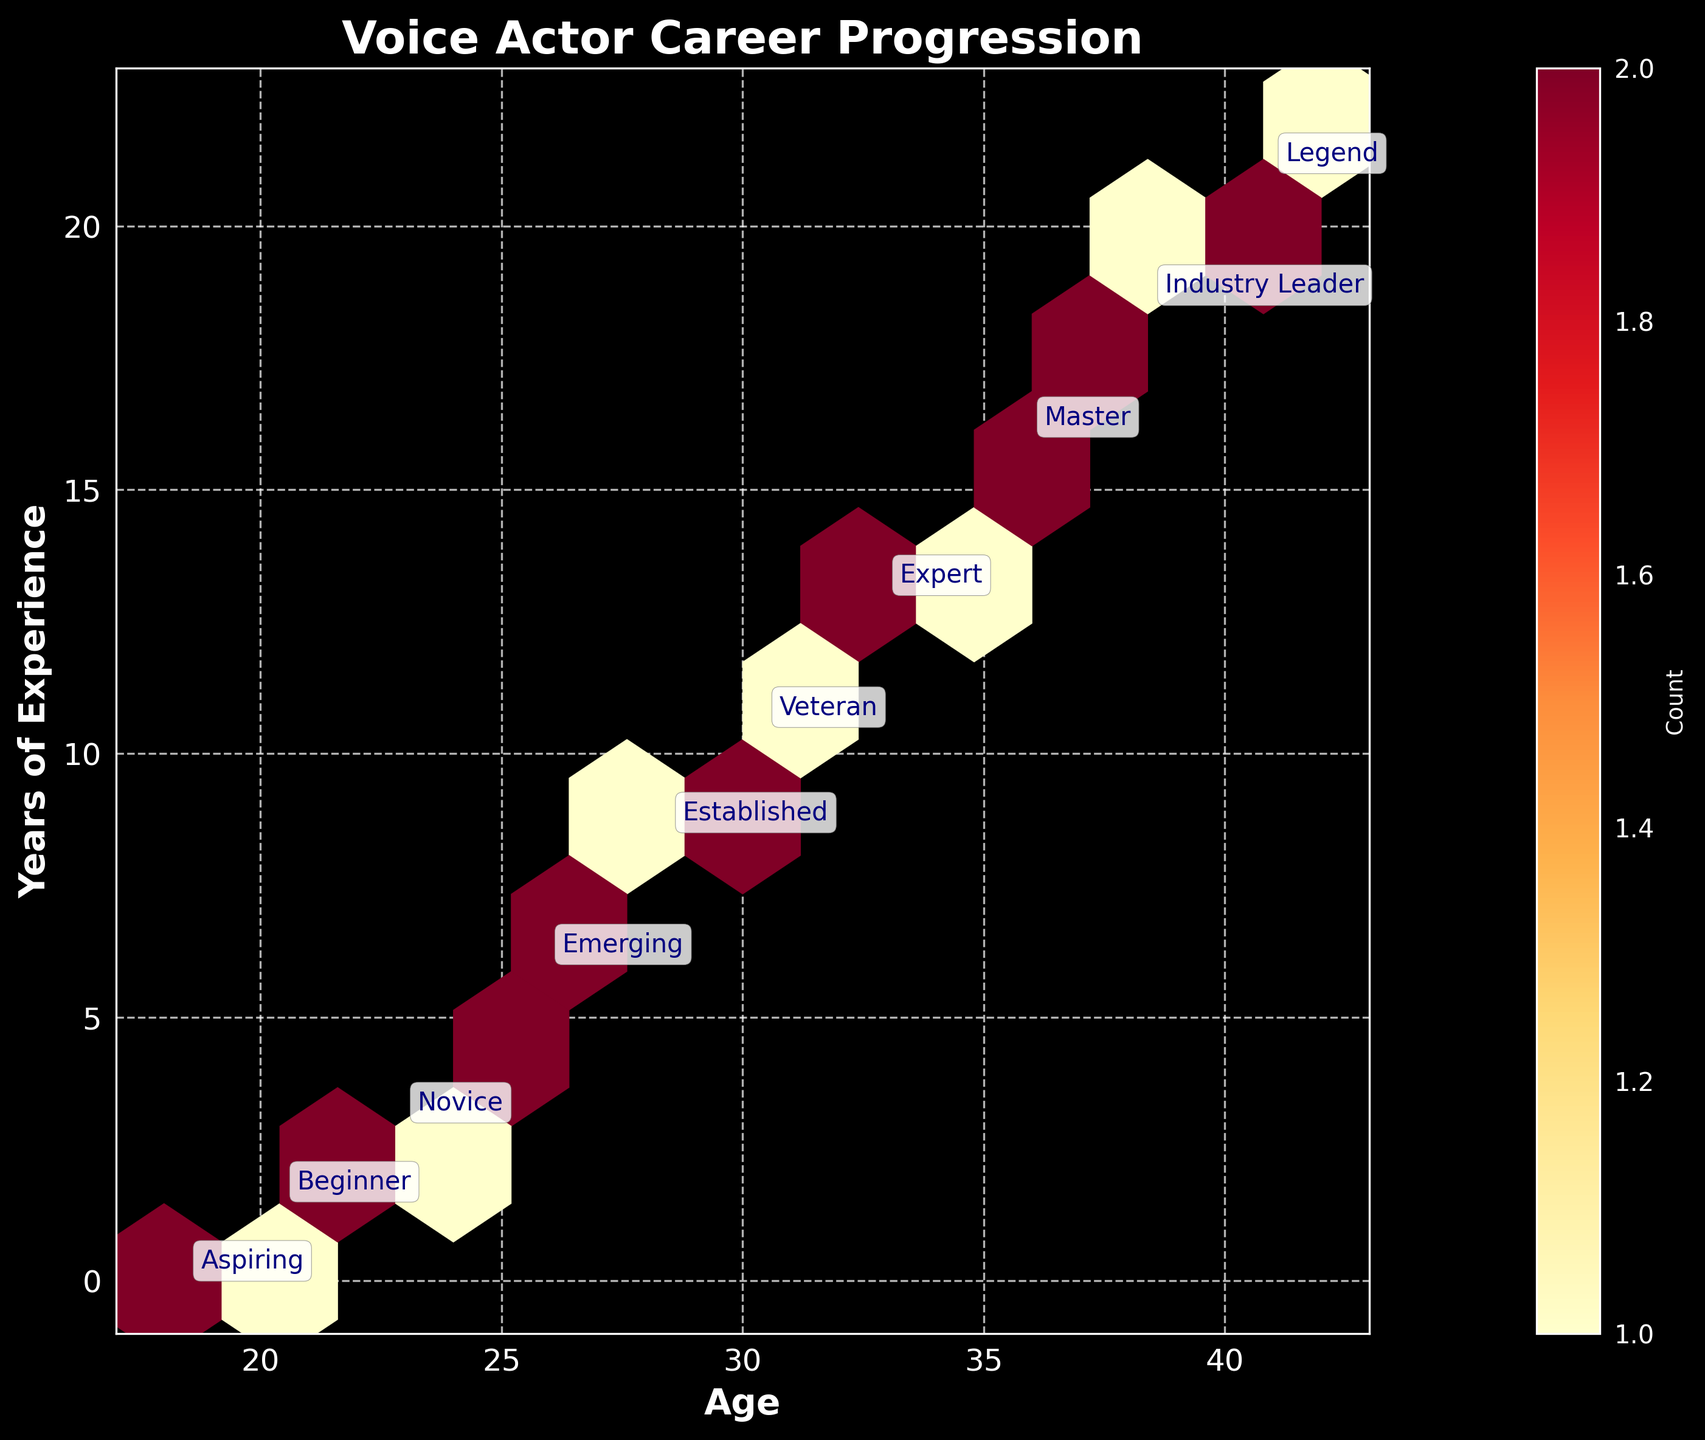what is the title of the plot? The title of the plot is typically shown at the top of the figure. In this case, the title 'Voice Actor Career Progression' is displayed prominently in bold and a larger font size than other text elements.
Answer: Voice Actor Career Progression What does the color scale in the hexbin plot represent? The color scale in the hexbin plot guides us on the count of data points in each hexagon. From the figure, the color transitions from a lighter yellow to a darker red, indicating an increasing number of data points in those areas.
Answer: Count of data points Between what ages is the data range? The x-axis of the plot represents age. The minimum and maximum tick values on the x-axis are 17 and 43, respectively. Since these values encompass the age range visible, the age data spans from 18 to 42 years.
Answer: 18 to 42 years Which career stage typically begins around the age of 30 with about 10 years of experience? We can look for the point annotations on the plot where the age is around 30 and years of experience is around 10. The annotated text 'Veteran' is closest to these coordinates.
Answer: Veteran What is the color of the hexbin where most "Aspiring" voice actors fall? To determine this, observe where aspiring actors are marked on the plot and note the hexbin's color around those markers, typically located at earlier ages and lower experience levels. The annotation 'Aspiring' is marked roughly around the age 18 and 19 with 0 years of experience.
Answer: Light Yellow What age group seems to have the highest concentration of data points for "Expert" level voice actors? To find this, identify the annotation for 'Expert' and its surrounding hexbin density. The 'Expert' level is annotated closer to the midpoint between the coordinates, around age 32 and 12 years of experience, indicating the highest concentration around this age and experience level.
Answer: Around age 32 How many career stages are represented in the plot? Each unique annotation represents a career stage. By counting the distinct annotations on the plot, we can determine the number of career stages.
Answer: 10 Which career stage has the widest spread of ages according to the plot? Note which career stage annotations stretch across the widest age range. The 'Legend' annotation appears both at age 40 and at the far end towards age 42, indicating a wider spread compared to other stages.
Answer: Legend 